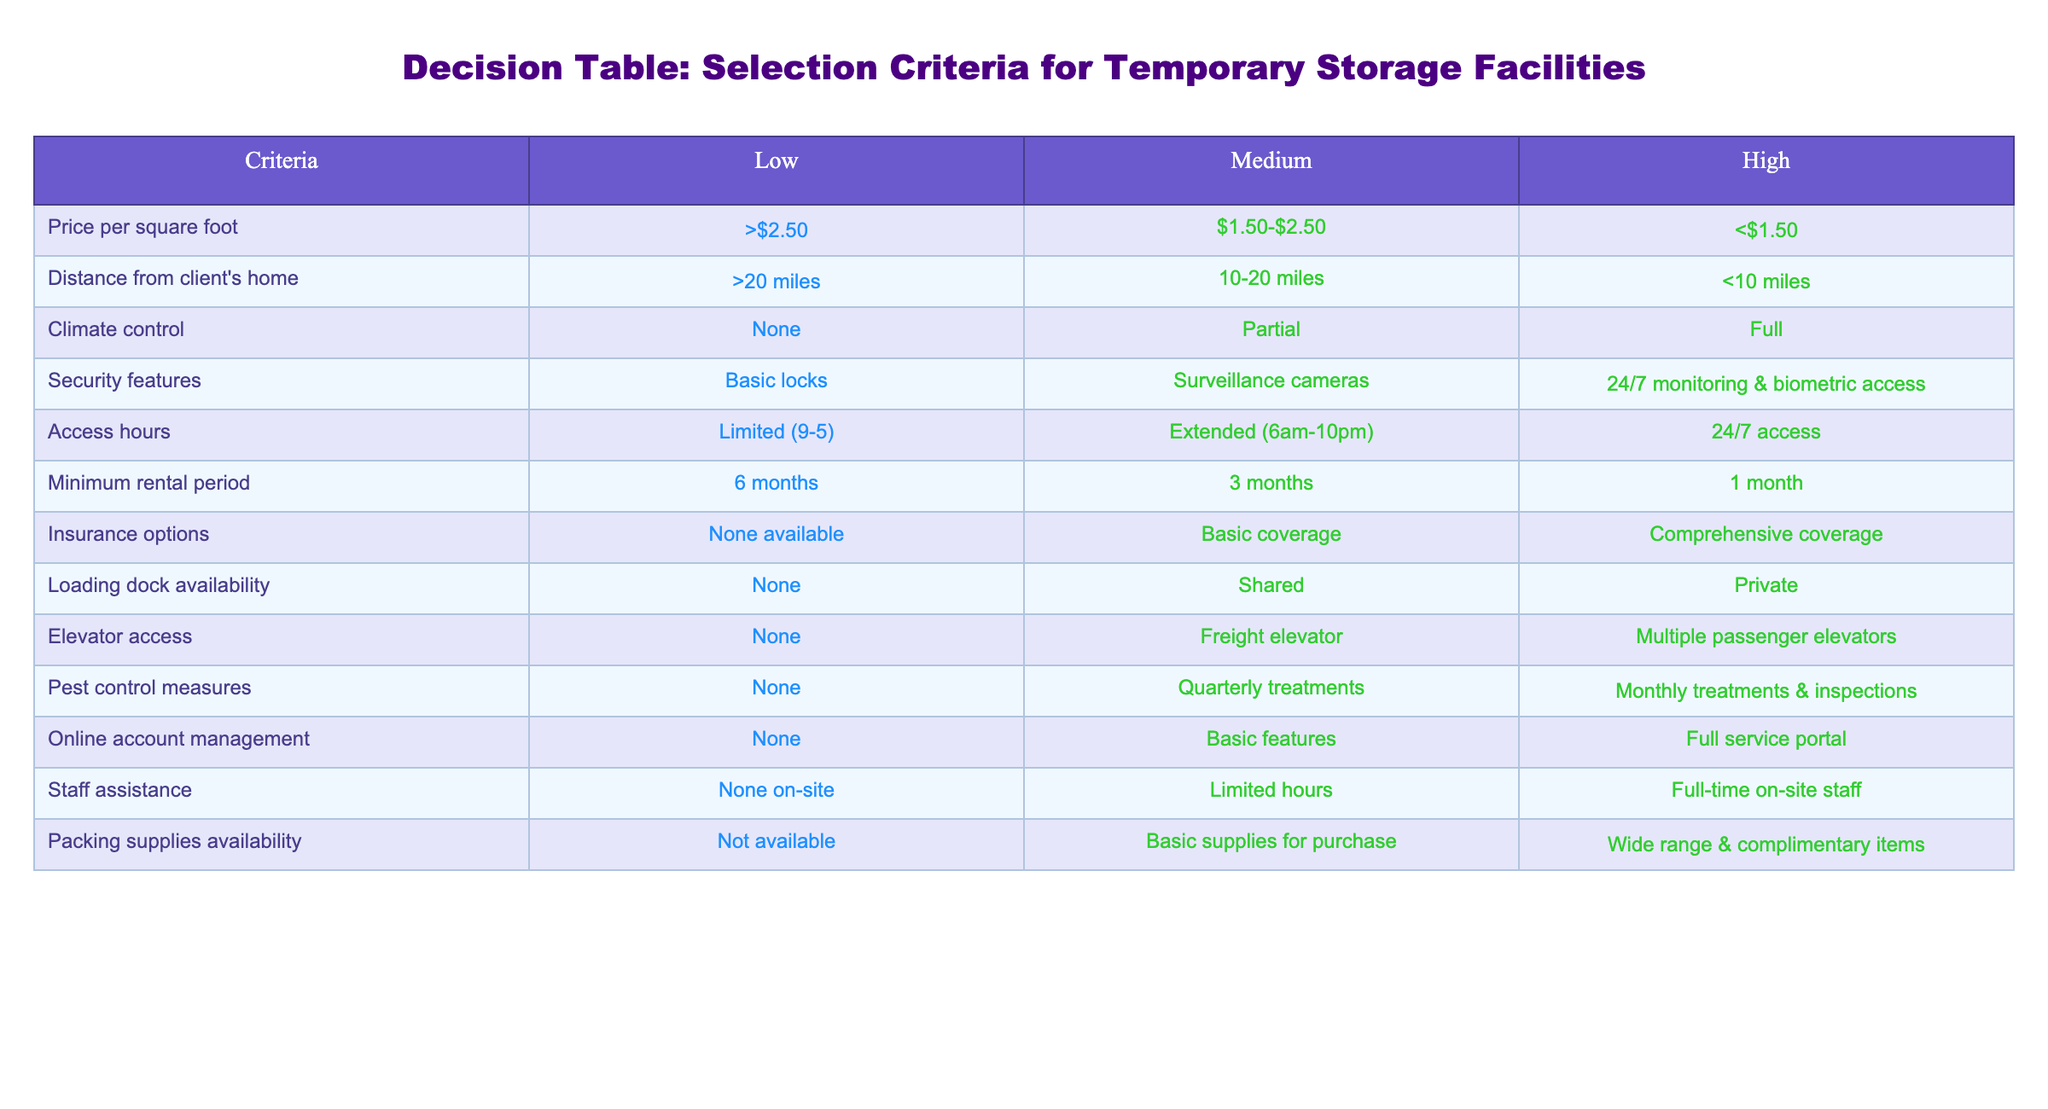What is the highest price per square foot for a temporary storage facility? According to the table, under the "Price per square foot" criteria, the high range is listed as less than $1.50. Thus, the highest price per square foot is just below $1.50.
Answer: Less than $1.50 Which security feature corresponds to the medium category? Looking at the "Security features" row, the medium category is described as having surveillance cameras.
Answer: Surveillance cameras Is there a minimum rental period that is less than 3 months? In the "Minimum rental period" row, the low category states a minimum rental period of 6 months, the medium category is 3 months, and the high category allows for 1 month. Thus, the answer is yes, there is an option of 1 month in the high category.
Answer: Yes How many categories offer full climate control? The "Climate control" row shows three categories: none (low), partial (medium), and full (high). The high category is the only one that offers full climate control. Thus, there is only one category available for full climate control.
Answer: One If a client requires 24/7 access, which security feature should they consider? The "Access hours" row states that 24/7 access is available in the high category, while the "Security features" row shows that for high security, there is 24/7 monitoring & biometric access. Therefore, clients needing 24/7 access should consider the high category for both access hours and security features.
Answer: 24/7 monitoring & biometric access What is the difference in loading dock availability between the high and low categories? In the "Loading dock availability" row, the low category offers no loading dock, while the high category specifies a private loading dock. The difference here is that the high category has dedicated access while the low category does not have any loading dock at all.
Answer: Private loading dock vs. None Is comprehensive insurance available for all categories? From the "Insurance options" row, none is available in the low category, basic coverage in the medium category, and comprehensive coverage in the high category. This indicates that comprehensive insurance is not available in all categories but only in the high category.
Answer: No What can be inferred about pest control measures if a client opts for the medium category? The "Pest control measures" row shows that the medium category includes quarterly treatments. Therefore, if a client opts for the medium pest control measures category, they can expect quarterly pest treatments.
Answer: Quarterly treatments How does the availability of staff assistance change from low to high category? In the "Staff assistance" row, no assistance is noted in the low category, limited hours in the medium category, and full-time on-site staff in the high category. So, the change is from no assistance to full-time assistance, indicating an increase in the availability of support for clients as they move from low to high categories.
Answer: No assistance to full-time assistance 